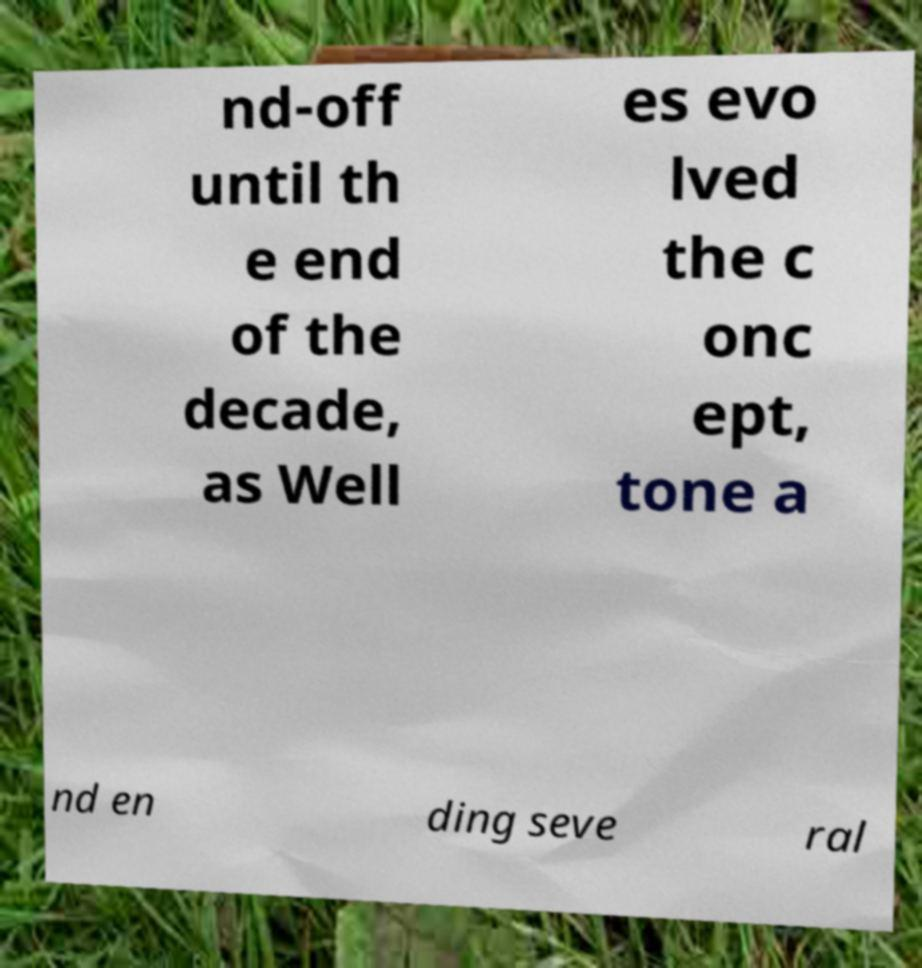There's text embedded in this image that I need extracted. Can you transcribe it verbatim? nd-off until th e end of the decade, as Well es evo lved the c onc ept, tone a nd en ding seve ral 